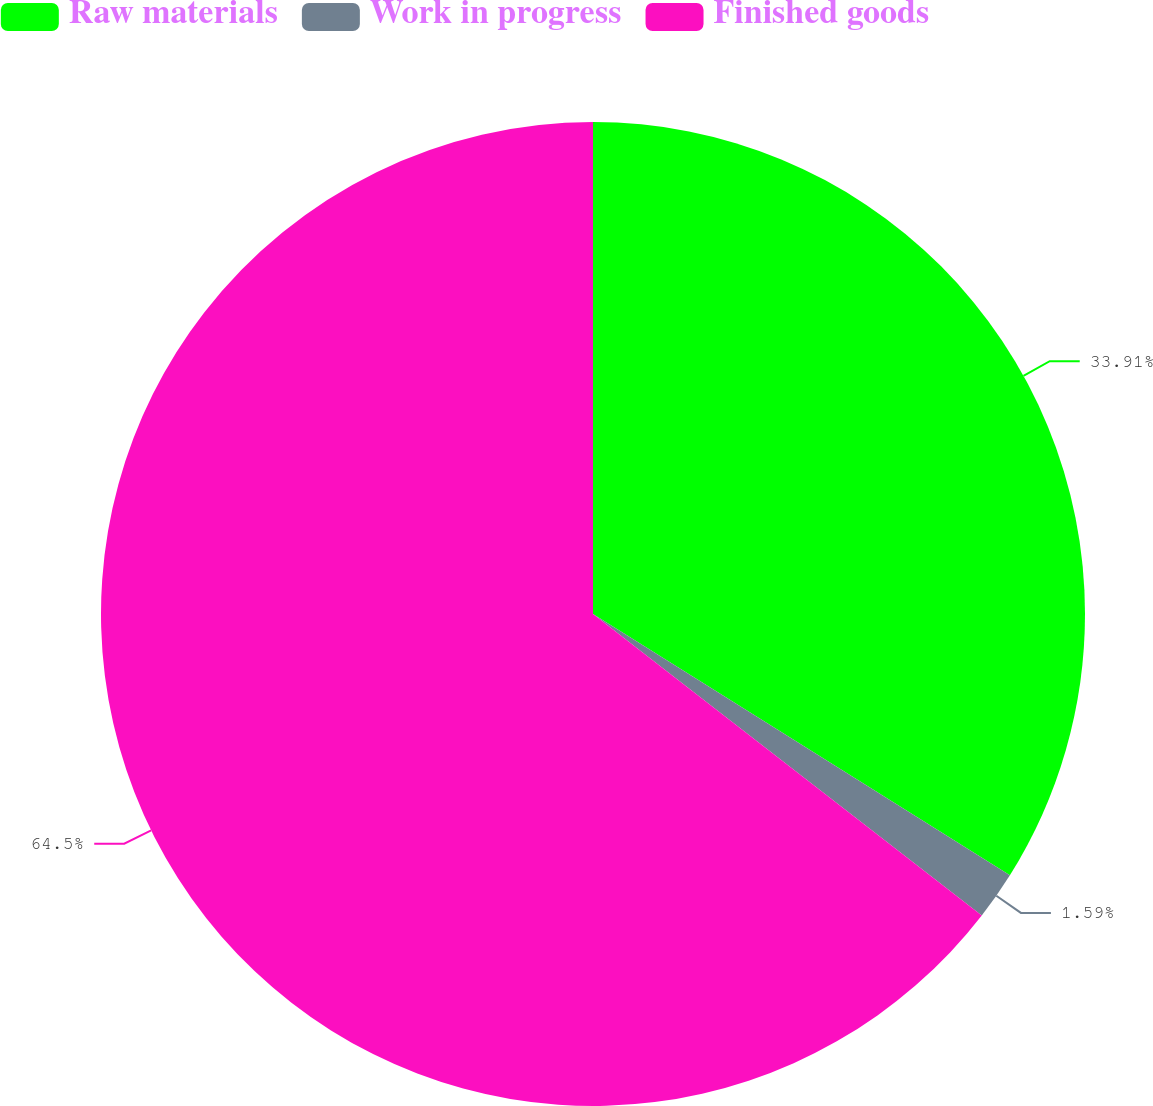Convert chart to OTSL. <chart><loc_0><loc_0><loc_500><loc_500><pie_chart><fcel>Raw materials<fcel>Work in progress<fcel>Finished goods<nl><fcel>33.91%<fcel>1.59%<fcel>64.5%<nl></chart> 